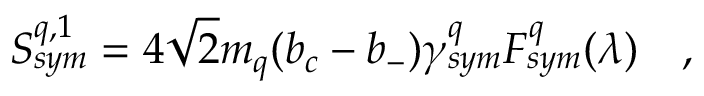Convert formula to latex. <formula><loc_0><loc_0><loc_500><loc_500>S _ { s y m } ^ { q , 1 } = 4 \sqrt { 2 } m _ { q } ( b _ { c } - b _ { - } ) \gamma _ { s y m } ^ { q } F _ { s y m } ^ { q } ( \lambda ) \quad ,</formula> 